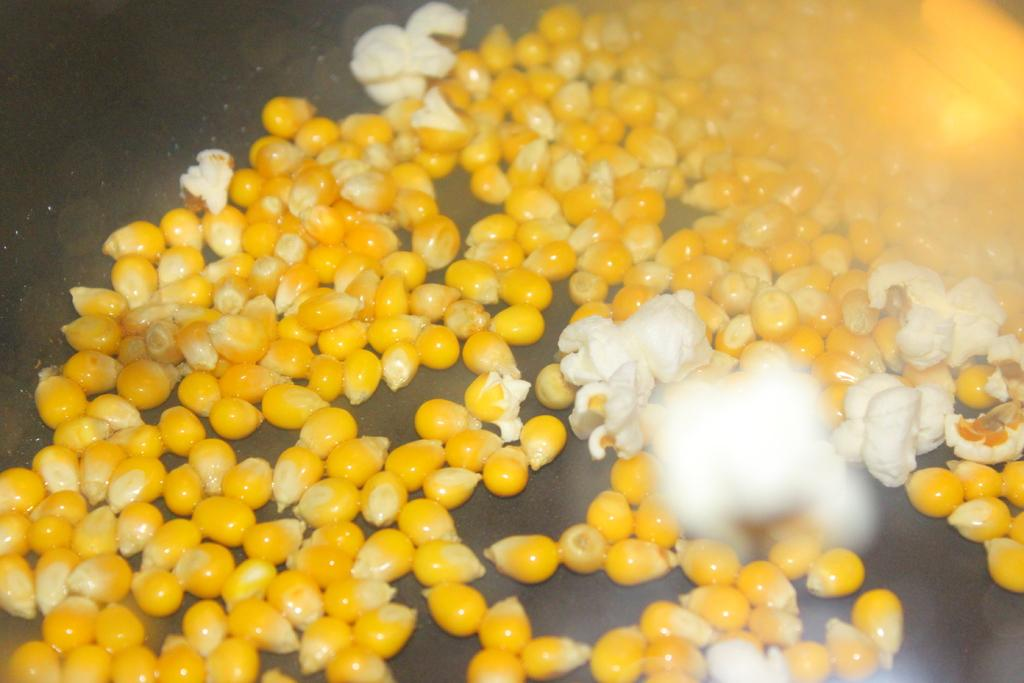What type of plant is visible in the image? There is corn in the image. Can you describe the appearance of the corn? The corn appears to be mature and has multiple rows of kernels. What might be the purpose of the corn in the image? The corn may be intended for consumption or for use as a decorative element. What type of underwear is visible in the image? There is no underwear present in the image; it only features corn. Can you tell me the story behind the corn in the image? There is no story provided in the image; it simply shows corn without any context or narrative. 